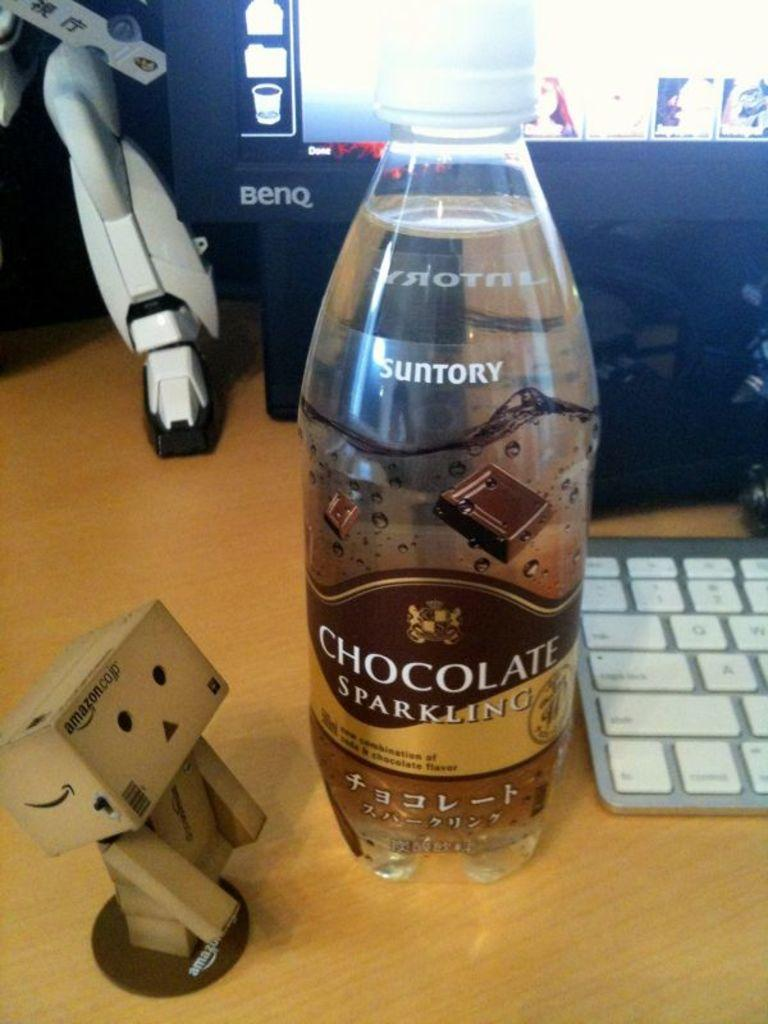Provide a one-sentence caption for the provided image. A bottle of chocolate sparkling water sits near a computer on a desk. 